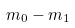Convert formula to latex. <formula><loc_0><loc_0><loc_500><loc_500>m _ { 0 } - m _ { 1 }</formula> 